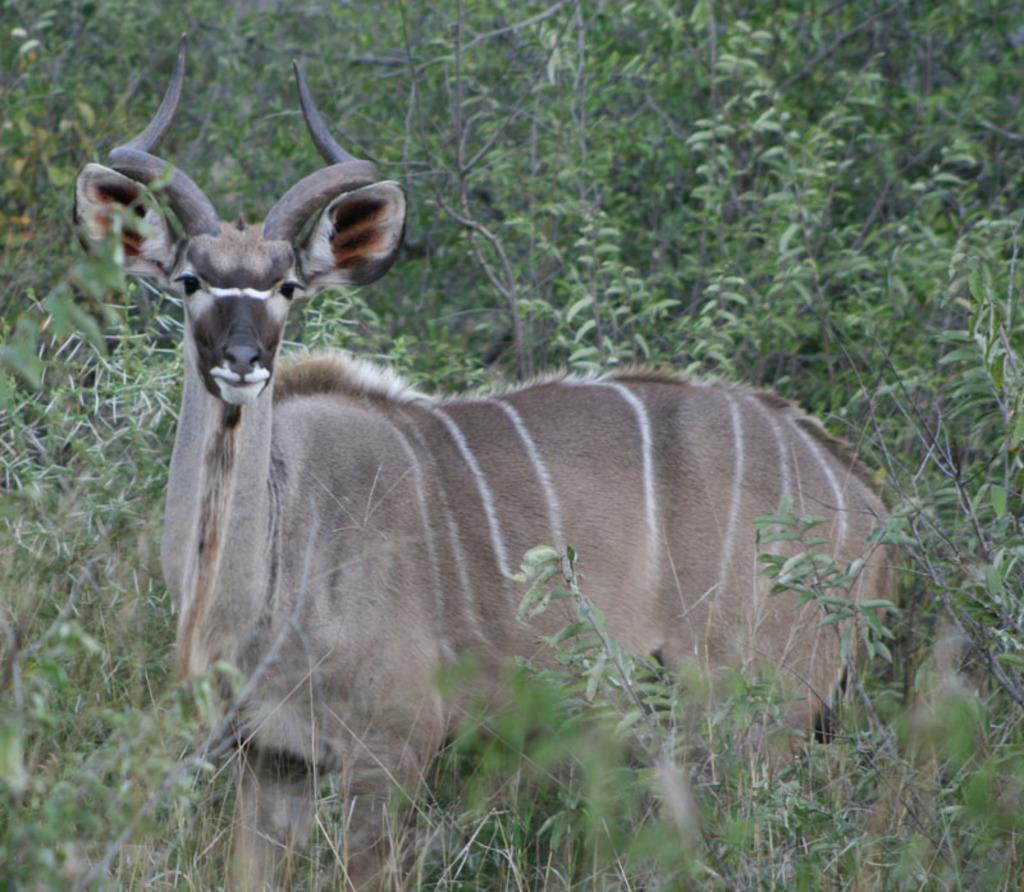Please provide a concise description of this image. In this picture there is an animal. At the back there are trees and the animal is in light brown color and there are white lines on the animal. 